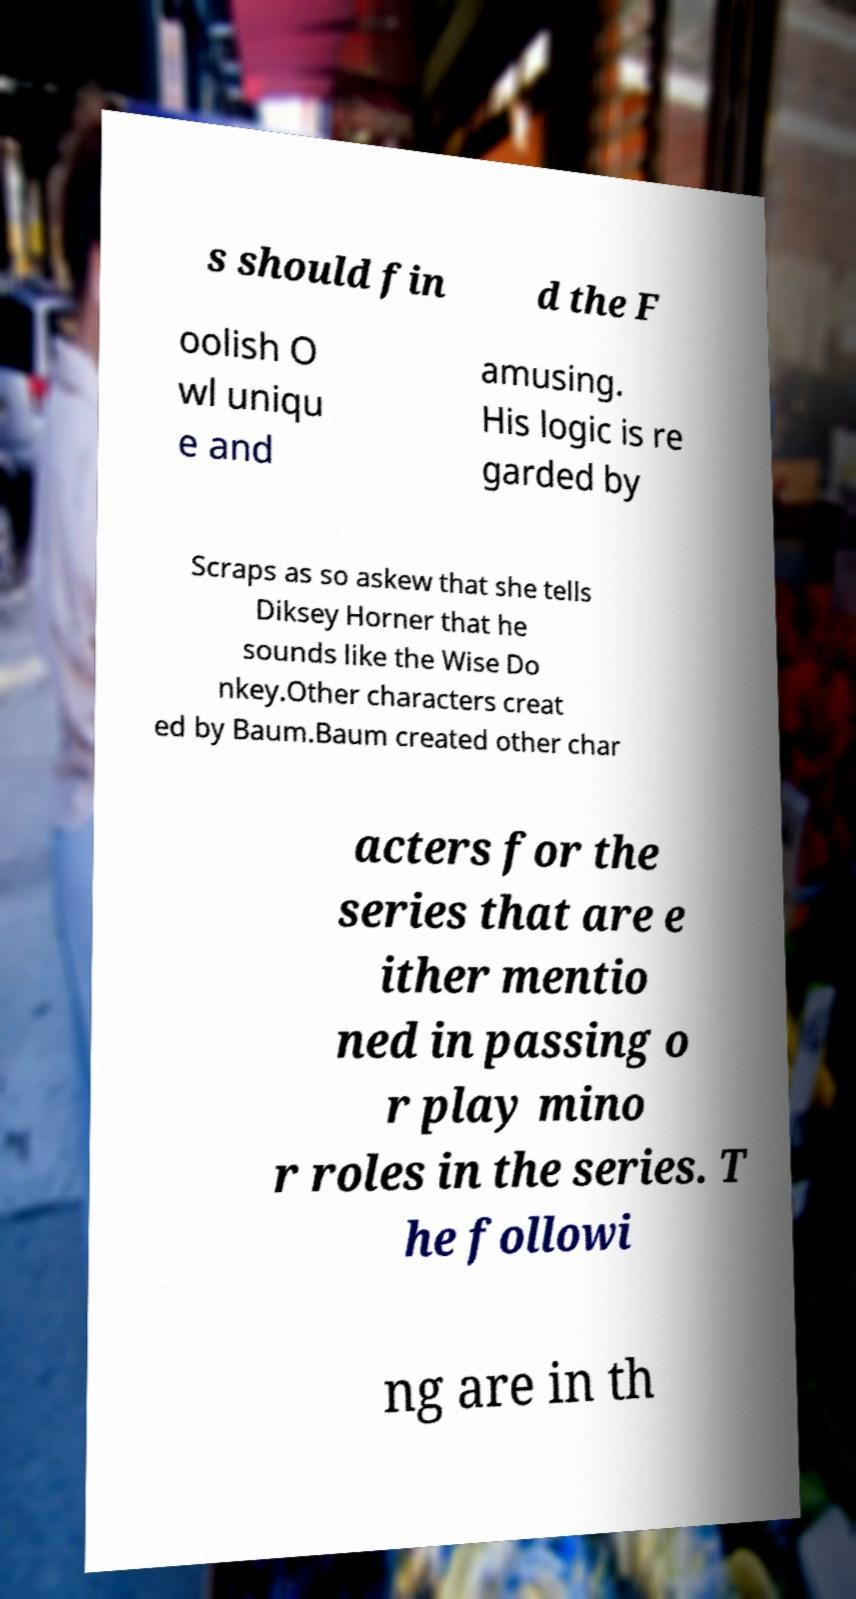Could you extract and type out the text from this image? s should fin d the F oolish O wl uniqu e and amusing. His logic is re garded by Scraps as so askew that she tells Diksey Horner that he sounds like the Wise Do nkey.Other characters creat ed by Baum.Baum created other char acters for the series that are e ither mentio ned in passing o r play mino r roles in the series. T he followi ng are in th 